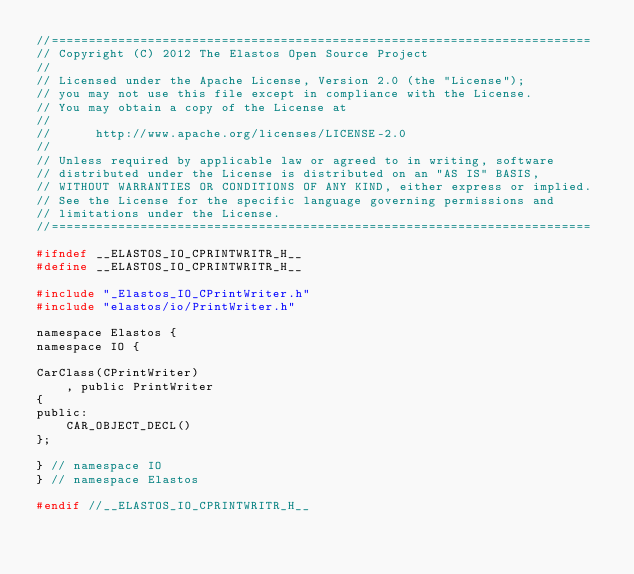Convert code to text. <code><loc_0><loc_0><loc_500><loc_500><_C_>//=========================================================================
// Copyright (C) 2012 The Elastos Open Source Project
//
// Licensed under the Apache License, Version 2.0 (the "License");
// you may not use this file except in compliance with the License.
// You may obtain a copy of the License at
//
//      http://www.apache.org/licenses/LICENSE-2.0
//
// Unless required by applicable law or agreed to in writing, software
// distributed under the License is distributed on an "AS IS" BASIS,
// WITHOUT WARRANTIES OR CONDITIONS OF ANY KIND, either express or implied.
// See the License for the specific language governing permissions and
// limitations under the License.
//=========================================================================

#ifndef __ELASTOS_IO_CPRINTWRITR_H__
#define __ELASTOS_IO_CPRINTWRITR_H__

#include "_Elastos_IO_CPrintWriter.h"
#include "elastos/io/PrintWriter.h"

namespace Elastos {
namespace IO {

CarClass(CPrintWriter)
    , public PrintWriter
{
public:
    CAR_OBJECT_DECL()
};

} // namespace IO
} // namespace Elastos

#endif //__ELASTOS_IO_CPRINTWRITR_H__
</code> 